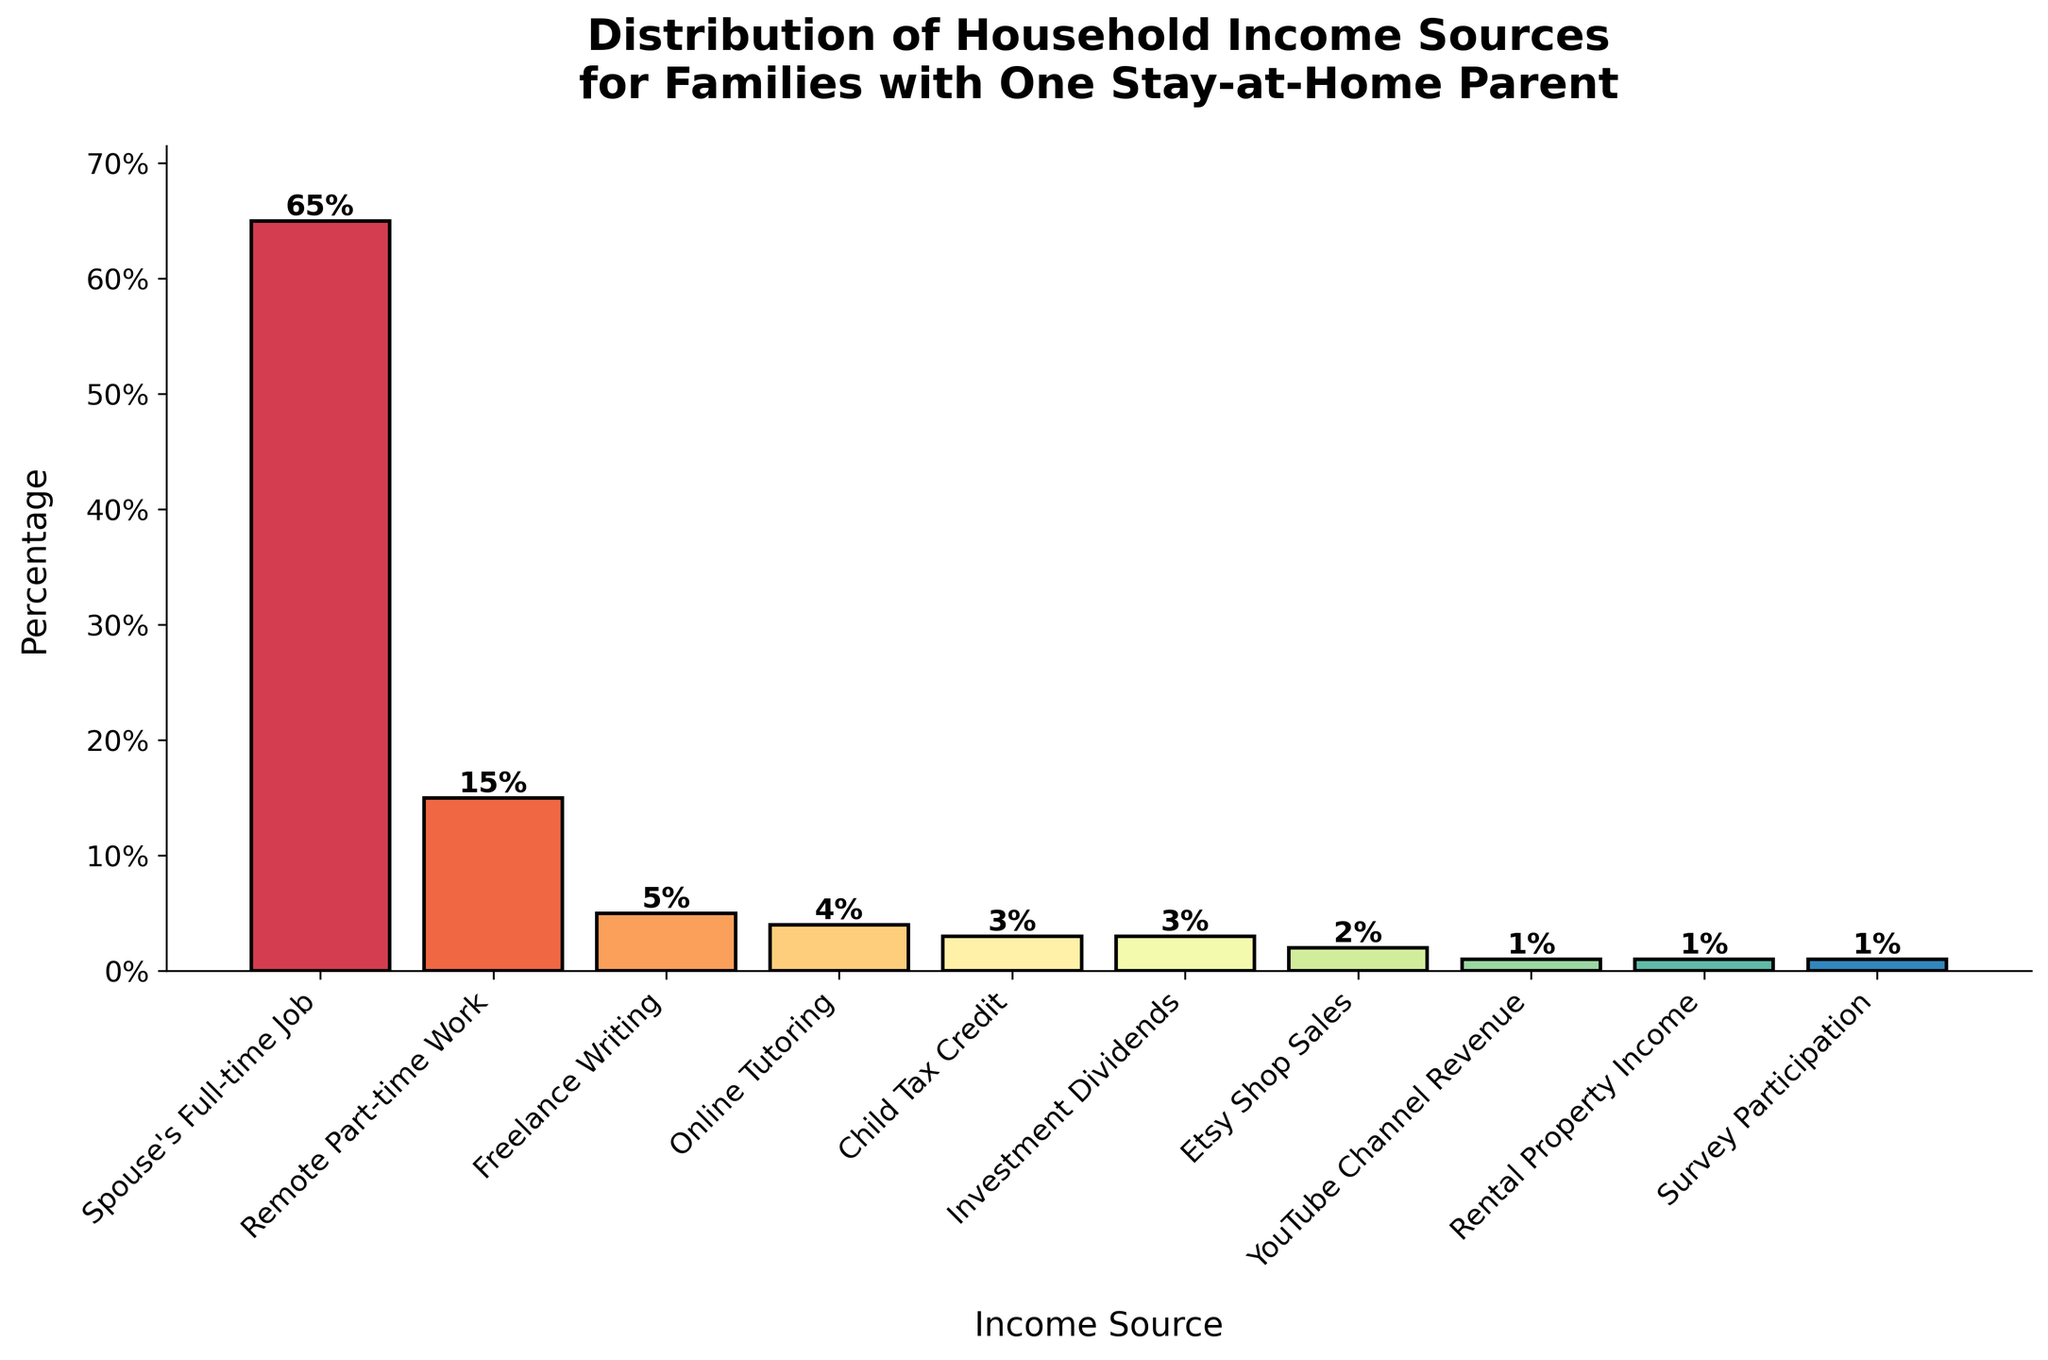What's the largest income source and its percentage? The largest income source can be identified by observing the tallest bar. The tallest bar represents "Spouse's Full-time Job" with a percentage of 65%.
Answer: Spouse's Full-time Job, 65% What's the combined percentage of income from Remote Part-time Work and Freelance Writing? Add the percentages for "Remote Part-time Work" (15%) and "Freelance Writing" (5%). 15% + 5% = 20%.
Answer: 20% Which income source contributes less than 5% but more than 1%? Look for bars whose heights represent percentages between 1% and 5%. "Online Tutoring" at 4%, "Child Tax Credit" at 3%, and "Investment Dividends" at 3% fall in this range.
Answer: Online Tutoring, Child Tax Credit, Investment Dividends What is the percentage difference between Spouse's Full-time Job and Remote Part-time Work? Subtract the percentage for "Remote Part-time Work" (15%) from "Spouse's Full-time Job" (65%). 65% - 15% = 50%.
Answer: 50% How many income sources contribute exactly 1%? Count the number of bars at the 1% value. "YouTube Channel Revenue," "Rental Property Income," and "Survey Participation" each contribute 1%, giving a total of 3 sources.
Answer: 3 Which is more significant: income from Freelance Writing or Online Tutoring? Compare the heights of the bars for "Freelance Writing" (5%) and "Online Tutoring" (4%). Freelance Writing has a higher percentage.
Answer: Freelance Writing How does the sum of income percentages from Etsy Shop Sales and YouTube Channel Revenue compare to Investment Dividends? Add the percentages for "Etsy Shop Sales" (2%) and "YouTube Channel Revenue" (1%). 2% + 1% = 3%, which is equal to "Investment Dividends" (3%).
Answer: They are equal What is the overall contribution of the top three income sources? Add the percentages for "Spouse's Full-time Job" (65%), "Remote Part-time Work" (15%), and "Freelance Writing" (5%). 65% + 15% + 5% = 85%.
Answer: 85% What percentage of income sources contribute less than 10% each? Identify all income sources with bars less than 10%. These are "Remote Part-time Work" (15%), "Freelance Writing" (5%), "Online Tutoring" (4%), "Child Tax Credit" (3%), "Investment Dividends" (3%), "Etsy Shop Sales" (2%), "YouTube Channel Revenue" (1%), "Rental Property Income" (1%), and "Survey Participation" (1%). Sum their percentages: 15% + 5% + 4% + 3% + 3% + 2% + 1% + 1% + 1% = 35%.
Answer: 35% Which income source has the least contribution and what is its percentage? The shortest bar represents "Survey Participation", "YouTube Channel Revenue", and "Rental Property Income," each at 1%.
Answer: Survey Participation, YouTube Channel Revenue, Rental Property Income, 1% 